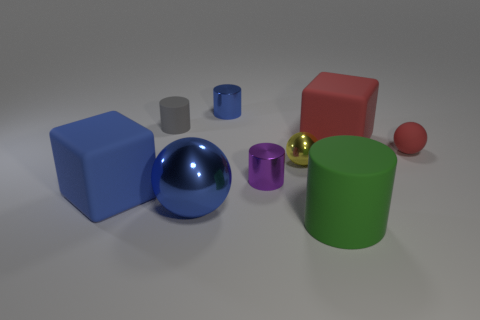What number of other things are the same color as the tiny matte sphere?
Offer a very short reply. 1. What number of large things are behind the small red matte object and in front of the tiny red object?
Your answer should be compact. 0. Is the number of blue metallic things in front of the small gray matte cylinder greater than the number of yellow metal spheres that are in front of the big green rubber object?
Offer a very short reply. Yes. What is the material of the cube that is behind the red matte sphere?
Offer a terse response. Rubber. Do the yellow shiny thing and the big matte thing that is in front of the blue cube have the same shape?
Ensure brevity in your answer.  No. There is a tiny yellow metal ball that is to the right of the tiny metal cylinder that is in front of the small blue thing; what number of tiny purple objects are on the right side of it?
Give a very brief answer. 0. The tiny matte thing that is the same shape as the large green object is what color?
Keep it short and to the point. Gray. Is there any other thing that is the same shape as the small gray matte object?
Provide a succinct answer. Yes. What number of blocks are big red rubber objects or tiny purple things?
Offer a terse response. 1. What is the shape of the purple object?
Ensure brevity in your answer.  Cylinder. 